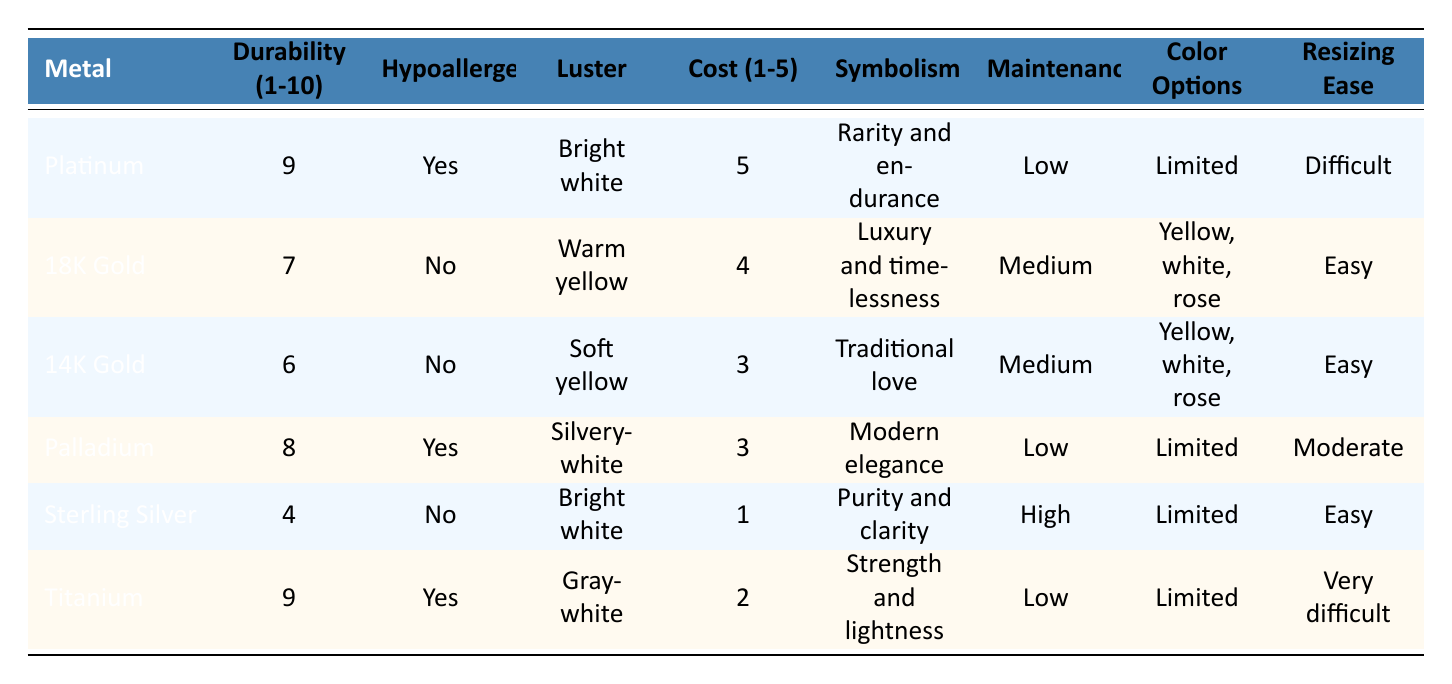What is the durability rating of Platinum? In the table, under the "Durability (1-10)" column, the durability rating for Platinum is listed as 9.
Answer: 9 Which metals are hypoallergenic? Looking at the "Hypoallergenic" column, both Platinum, Palladium, and Titanium are marked as "Yes," indicating that they are hypoallergenic.
Answer: Platinum, Palladium, Titanium What is the cost rating of Sterling Silver? The "Cost (1-5)" column shows that Sterling Silver has a cost rating of 1, indicating it is the least expensive among the metals listed.
Answer: 1 Which metal has the highest durability rating, and what is its value? By checking the "Durability (1-10)" column, both Platinum and Titanium have the highest durability rating of 9.
Answer: Platinum and Titanium; 9 What is the average cost rating of the gold options (18K Gold and 14K Gold)? To find the average cost rating, first sum the cost ratings of 18K Gold (4) and 14K Gold (3) which gives 7. Then divide by the number of options: 7 / 2 = 3.5.
Answer: 3.5 Is there a metal that offers both high durability and hypoallergenic properties? From the table, Platinum and Titanium both have high durability ratings of 9 and are also marked as hypoallergenic with "Yes."
Answer: Yes What is the most expensive metal listed and what is its symbolism? The metal with the highest cost rating is Platinum, with a cost rating of 5, and its symbolism is "Rarity and endurance."
Answer: Platinum; Rarity and endurance For which metal is resizing the easiest? According to the "Resizing Ease" column, both 18K Gold and 14K Gold are marked as "Easy," indicating they can be resized without difficulty.
Answer: 18K Gold and 14K Gold Which metal has the least color options available? Reviewing the "Color Options" column, both Platinum, Palladium, and Titanium have "Limited" color options, making them the metals with the least variety in color.
Answer: Platinum, Palladium, Titanium What is the maintenance level of Sterling Silver? The "Maintenance" column indicates that Sterling Silver requires a "High" level of maintenance, meaning it needs frequent care.
Answer: High 